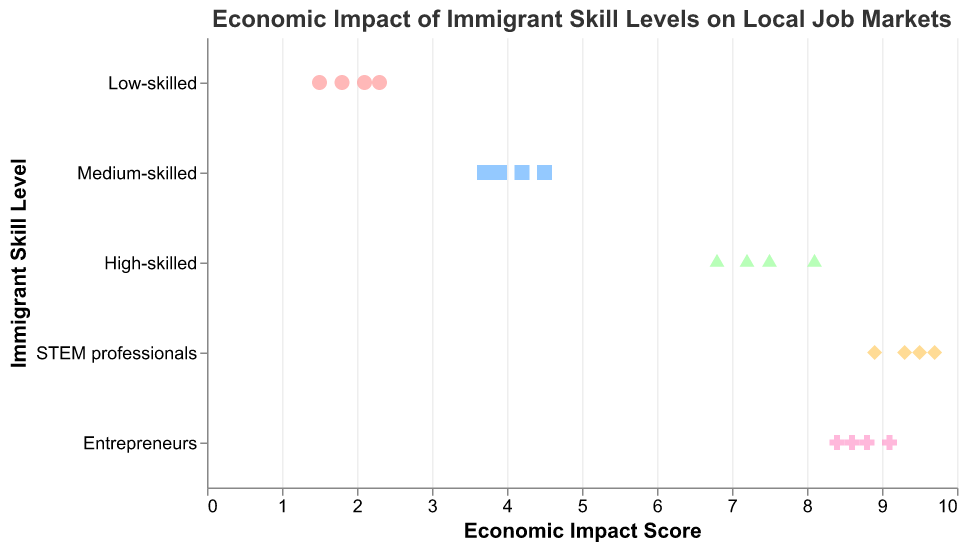What is the title of the plot? The title of the plot is displayed at the top of the figure. It is common to use titles to summarize the main theme or message of the plot.
Answer: Economic Impact of Immigrant Skill Levels on Local Job Markets What skill level has the highest economic impact scores? By observing the x-axis values and the points representing each skill level, we can see which group has the highest values.
Answer: STEM professionals Which colors represent Low-skilled and High-skilled immigrants? By looking at the legend or the unique color assignments for each skill level, we identify the corresponding colors.
Answer: Low-skilled: light red, High-skilled: light green What is the range of economic impact scores for Medium-skilled workers? We examine the distribution of points for Medium-skilled workers and note the minimum and maximum scores along the x-axis.
Answer: From 3.7 to 4.5 How many data points are there for STEM professionals? Count the number of points associated with STEM professionals. This can be done visually as the points are uniquely colored and shaped.
Answer: 4 What is the average economic impact score of Entrepreneurs? Sum the economic impact scores for Entrepreneurs and divide by the number of scores.
Answer: (8.6 + 9.1 + 8.4 + 8.8) / 4 = 8.725 Which skill level has the most consistent economic impact scores? Look for the group with the least variability in their impact scores, indicated by a narrow range of data points along the x-axis.
Answer: Entrepreneurs Do Low-skilled immigrants have any economic impact scores above 2.3? Check the plotted points for Low-skilled immigrants to see if any are positioned above the 2.3 mark on the x-axis.
Answer: No Is there any overlap in economic impact scores between High-skilled and STEM professionals? Compare the ranges of scores for both groups to determine if there are any common scores.
Answer: Yes, between 7.5 and 8.1 What are the possible economic impact scores for High-skilled workers? Identify all distinct x-axis values associated with High-skilled workers' points as shown in the plot.
Answer: 6.8, 7.2, 7.5, 8.1 